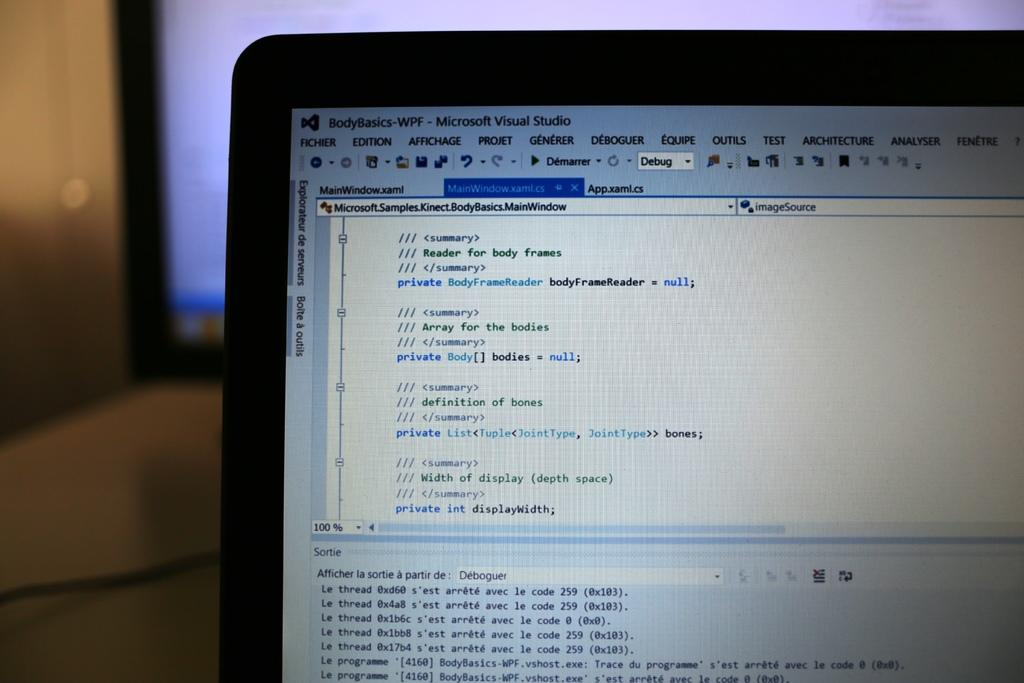<image>
Relay a brief, clear account of the picture shown. Someone is using Microsoft Visual Studio to study body basics. 